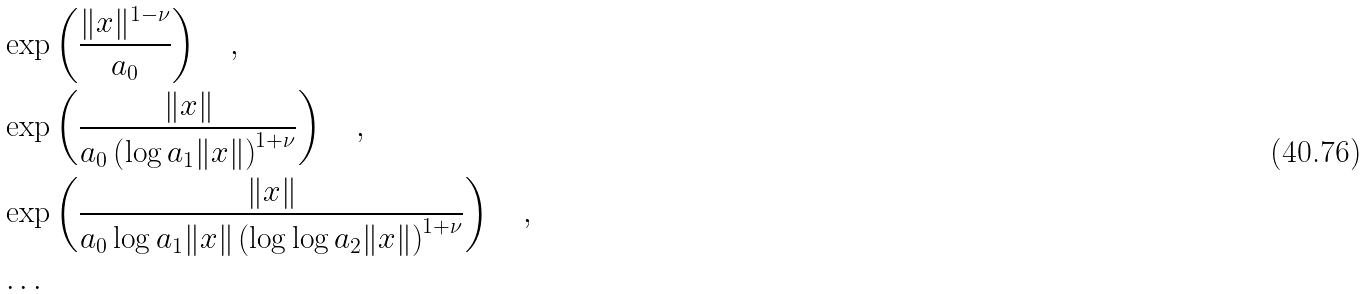Convert formula to latex. <formula><loc_0><loc_0><loc_500><loc_500>& \exp \left ( \frac { \| x \| ^ { 1 - \nu } } { a _ { 0 } } \right ) \quad , \\ & \exp \left ( \frac { \| x \| } { a _ { 0 } \left ( \log a _ { 1 } \| x \| \right ) ^ { 1 + \nu } } \right ) \quad , \\ & \exp \left ( \frac { \| x \| } { a _ { 0 } \log a _ { 1 } \| x \| \left ( \log \log a _ { 2 } \| x \| \right ) ^ { 1 + \nu } } \right ) \quad , \\ & \dots</formula> 